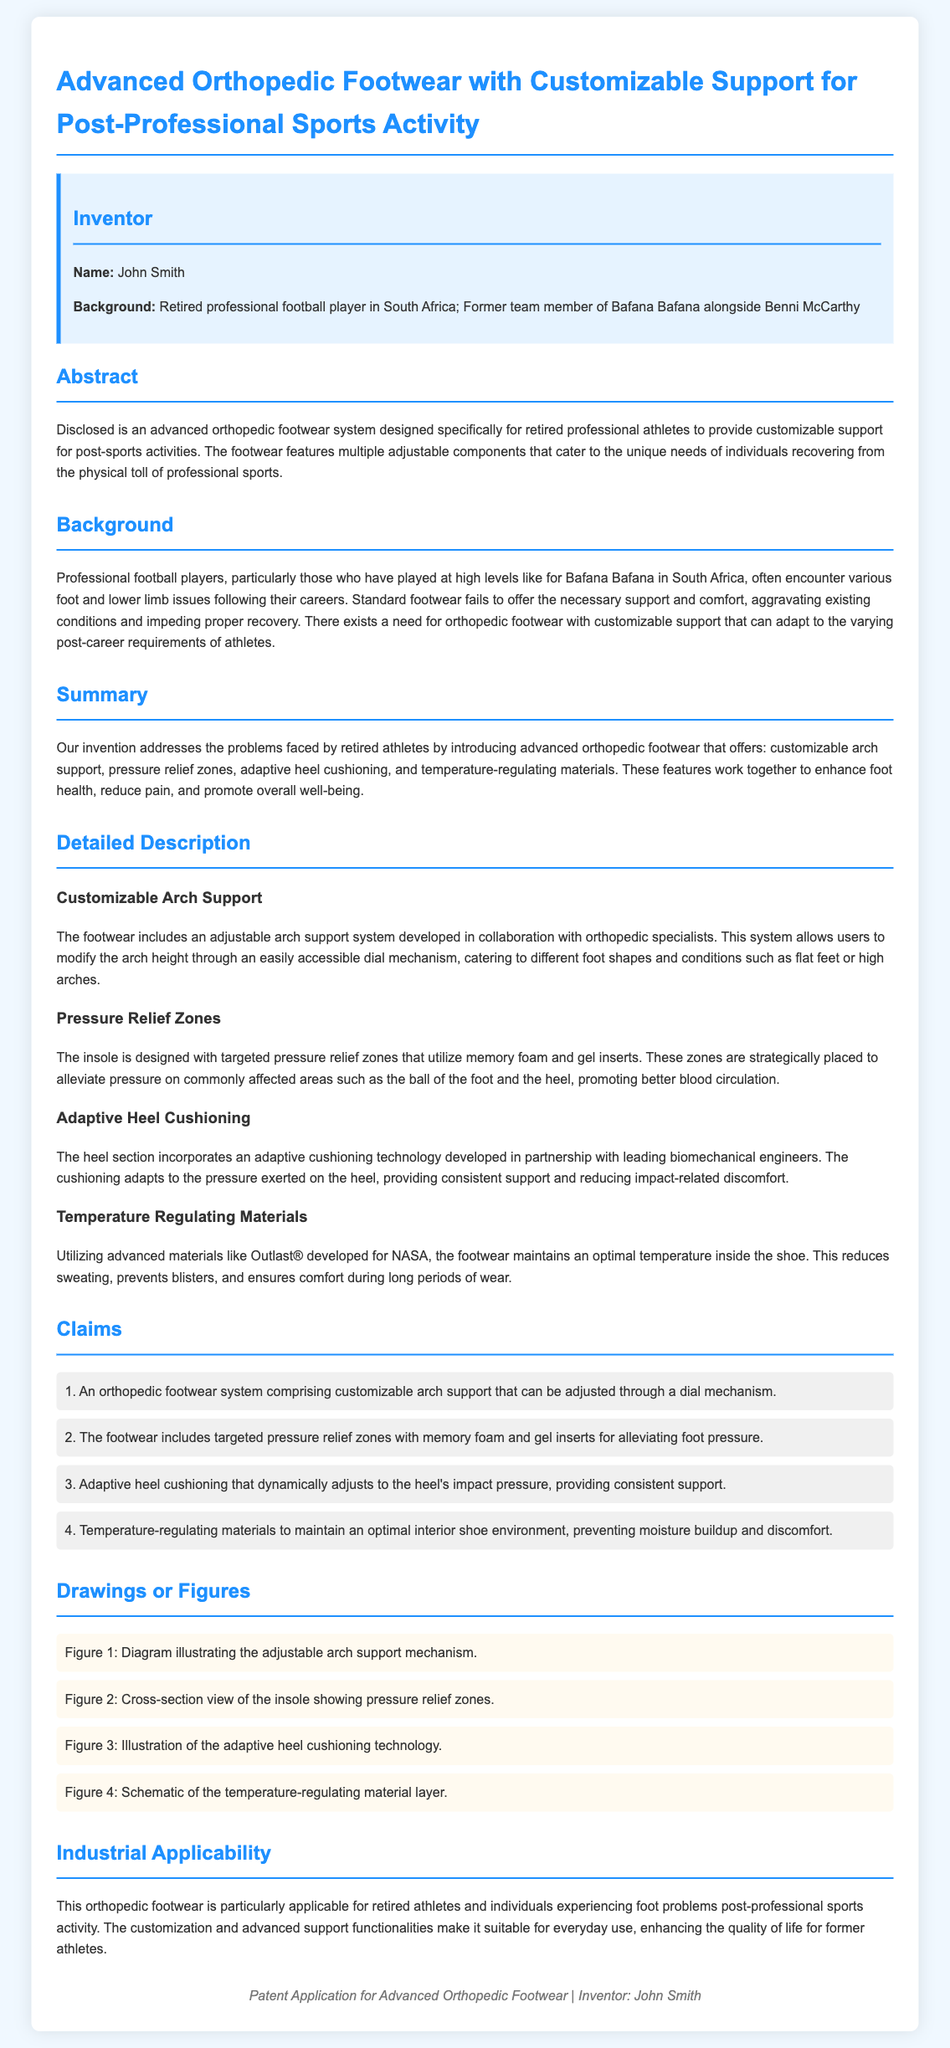what is the name of the inventor? The inventor's name is mentioned in the "Inventor" section, which states "John Smith."
Answer: John Smith what sports team did the inventor play for? It is stated in the background that the inventor played for "Bafana Bafana."
Answer: Bafana Bafana what is the main purpose of the patent? The abstract explains that the patent is designed to provide "customizable support for post-sports activities."
Answer: customizable support for post-sports activities what technology is used for temperature regulation? The detailed description states that the footwear utilizes materials like "Outlast® developed for NASA."
Answer: Outlast® how many claims are outlined in the patent? The claims section lists a total of four claims regarding the features of the footwear.
Answer: four what problem does this footwear aim to address for retired athletes? The document states that standard footwear fails to "offer the necessary support and comfort" post-career.
Answer: necessary support and comfort which feature allows adjustment of arch height? The customizable arch support system allows for arch height adjustment via a "dial mechanism."
Answer: dial mechanism what does the insole design include? The insole is designed with "targeted pressure relief zones" and foam inserts.
Answer: targeted pressure relief zones what kind of engineers collaborated on adaptive heel cushioning? The document specifies that leading "biomechanical engineers" worked on this aspect of the footwear.
Answer: biomechanical engineers what is a key benefit mentioned regarding pressure relief zones? The document states that these zones promote "better blood circulation."
Answer: better blood circulation 